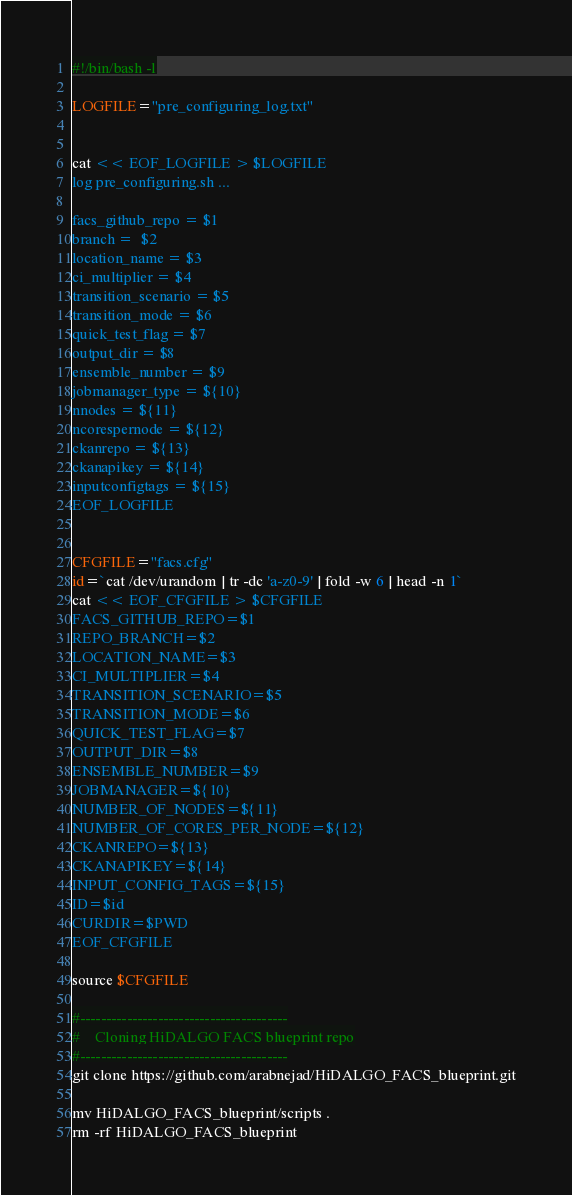Convert code to text. <code><loc_0><loc_0><loc_500><loc_500><_Bash_>#!/bin/bash -l

LOGFILE="pre_configuring_log.txt"


cat << EOF_LOGFILE > $LOGFILE
log pre_configuring.sh ...

facs_github_repo = $1
branch =  $2
location_name = $3
ci_multiplier = $4
transition_scenario = $5
transition_mode = $6
quick_test_flag = $7
output_dir = $8
ensemble_number = $9
jobmanager_type = ${10}
nnodes = ${11}
ncorespernode = ${12}
ckanrepo = ${13}
ckanapikey = ${14}
inputconfigtags = ${15}
EOF_LOGFILE


CFGFILE="facs.cfg"
id=`cat /dev/urandom | tr -dc 'a-z0-9' | fold -w 6 | head -n 1`
cat << EOF_CFGFILE > $CFGFILE
FACS_GITHUB_REPO=$1
REPO_BRANCH=$2
LOCATION_NAME=$3
CI_MULTIPLIER=$4
TRANSITION_SCENARIO=$5
TRANSITION_MODE=$6
QUICK_TEST_FLAG=$7
OUTPUT_DIR=$8
ENSEMBLE_NUMBER=$9
JOBMANAGER=${10}
NUMBER_OF_NODES=${11}
NUMBER_OF_CORES_PER_NODE=${12}
CKANREPO=${13}
CKANAPIKEY=${14}
INPUT_CONFIG_TAGS=${15}
ID=$id
CURDIR=$PWD
EOF_CFGFILE

source $CFGFILE

#----------------------------------------
#    Cloning HiDALGO FACS blueprint repo
#----------------------------------------
git clone https://github.com/arabnejad/HiDALGO_FACS_blueprint.git

mv HiDALGO_FACS_blueprint/scripts .
rm -rf HiDALGO_FACS_blueprint



</code> 